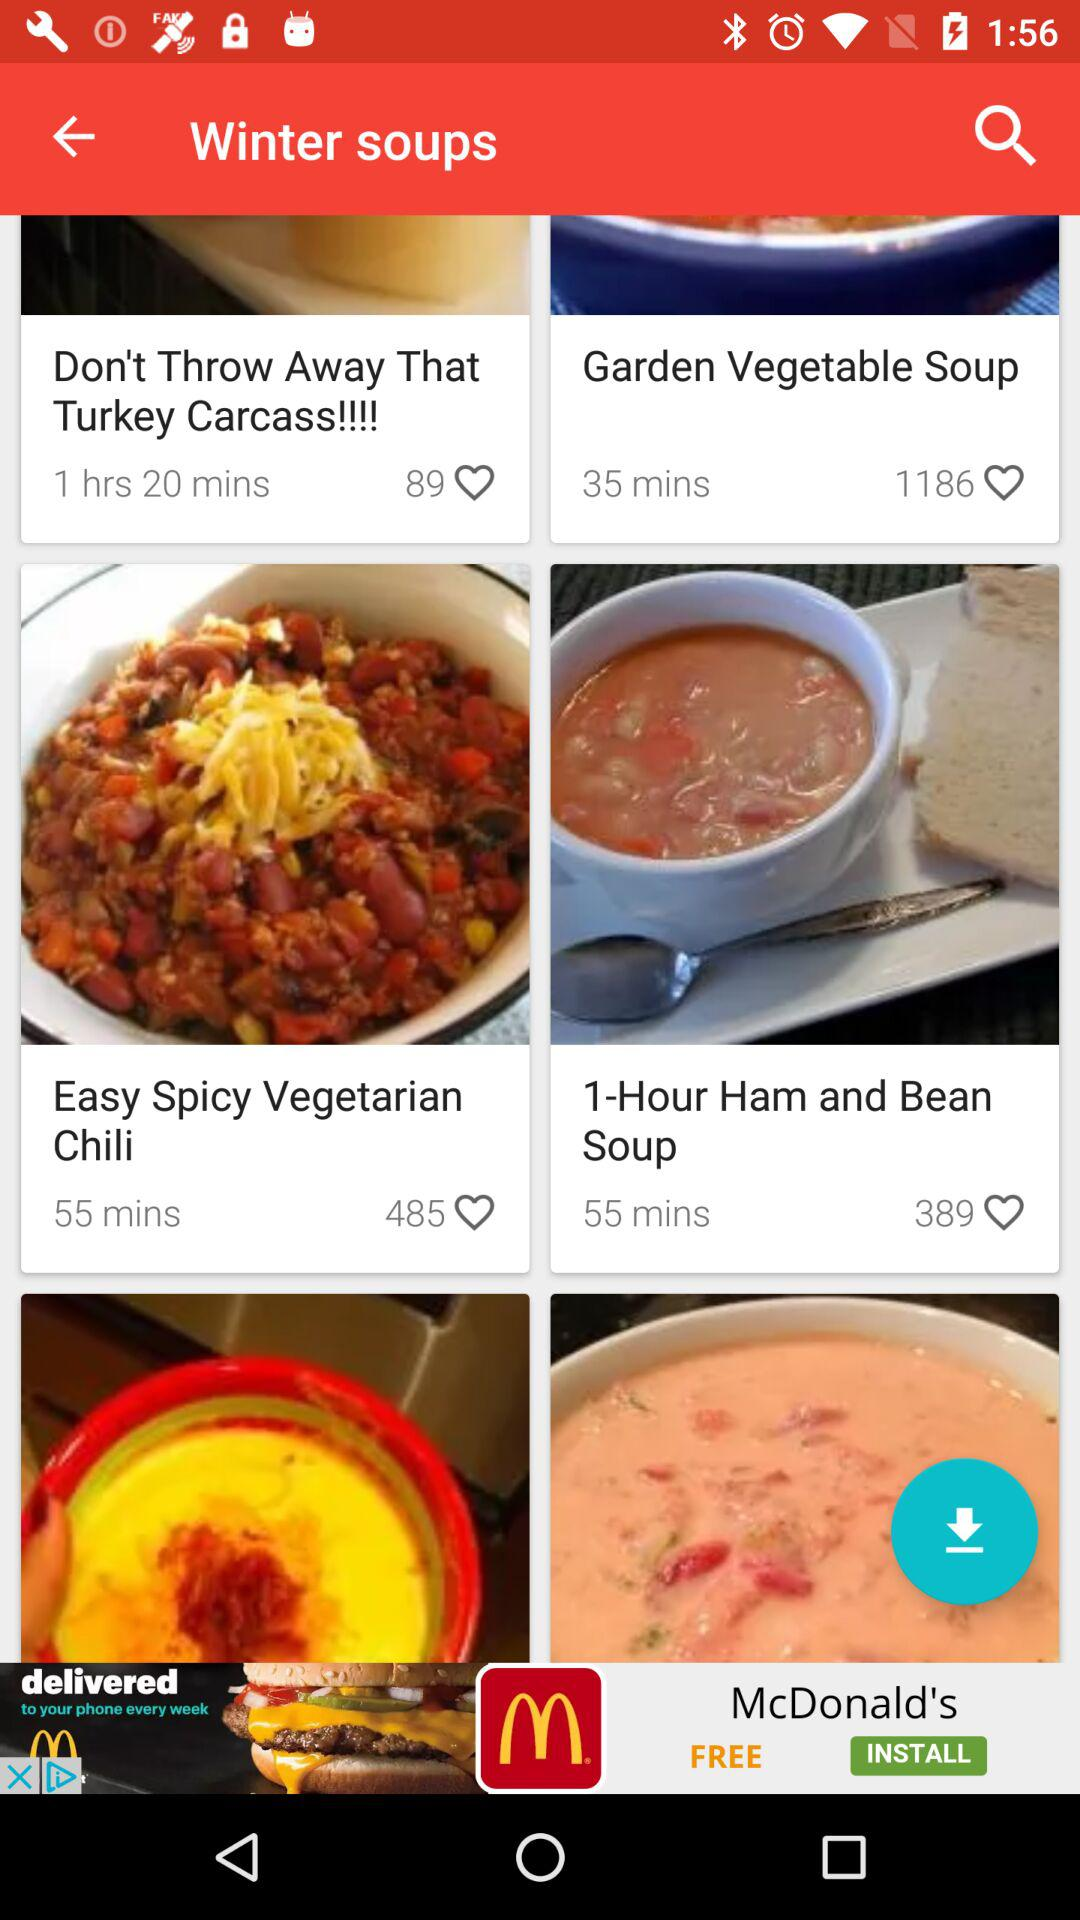Which soup has got the maximum number of likes?
When the provided information is insufficient, respond with <no answer>. <no answer> 